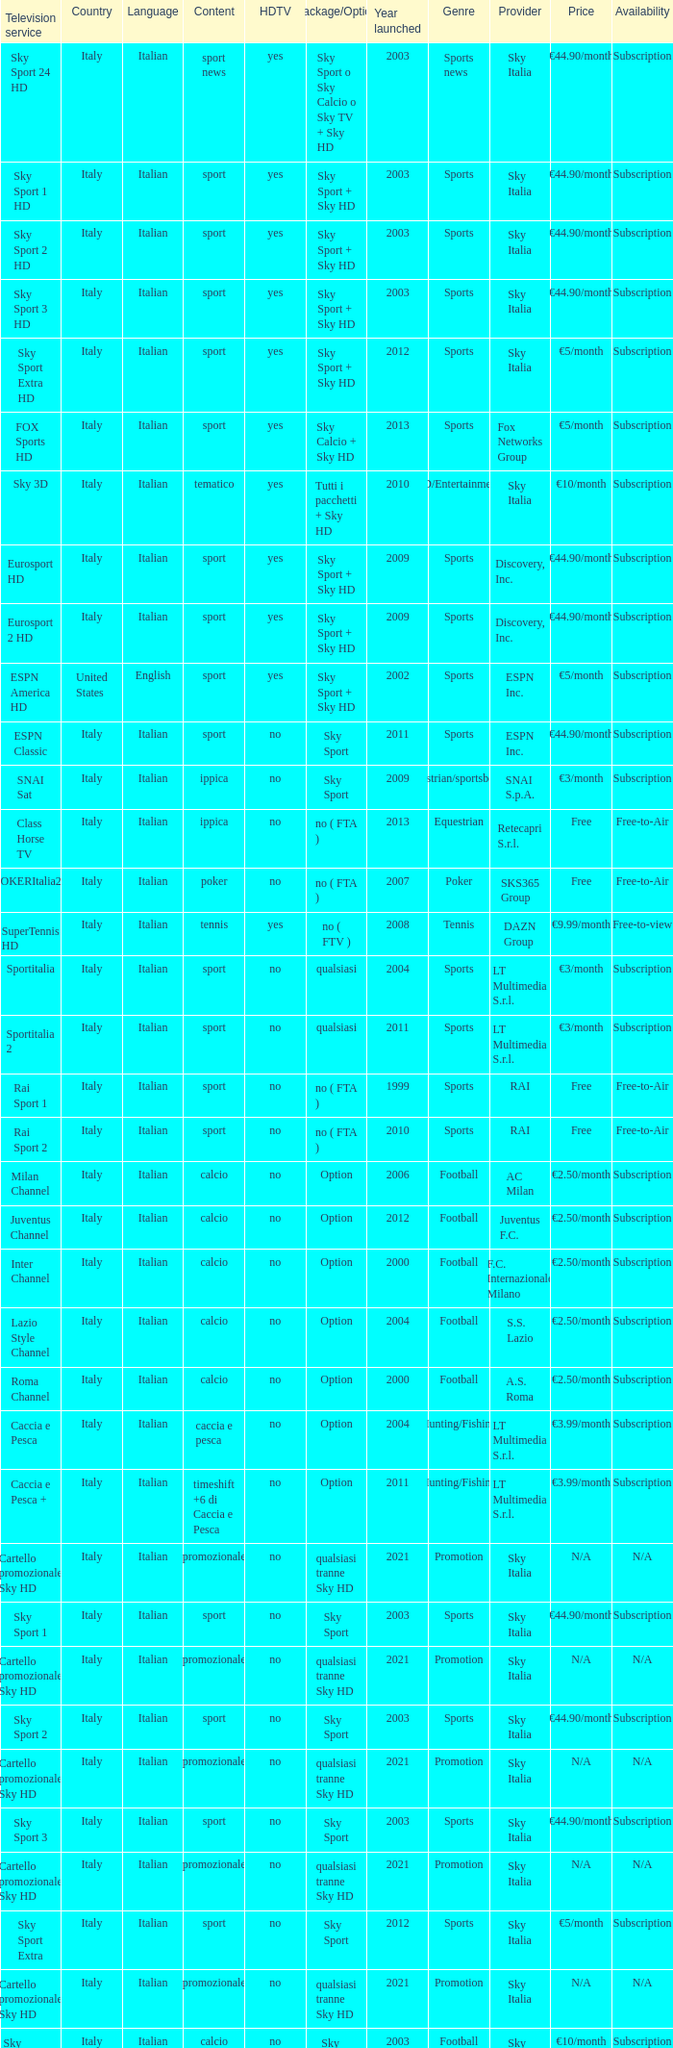What is Television Service, when Content is Calcio, and when Package/Option is Option? Milan Channel, Juventus Channel, Inter Channel, Lazio Style Channel, Roma Channel. 